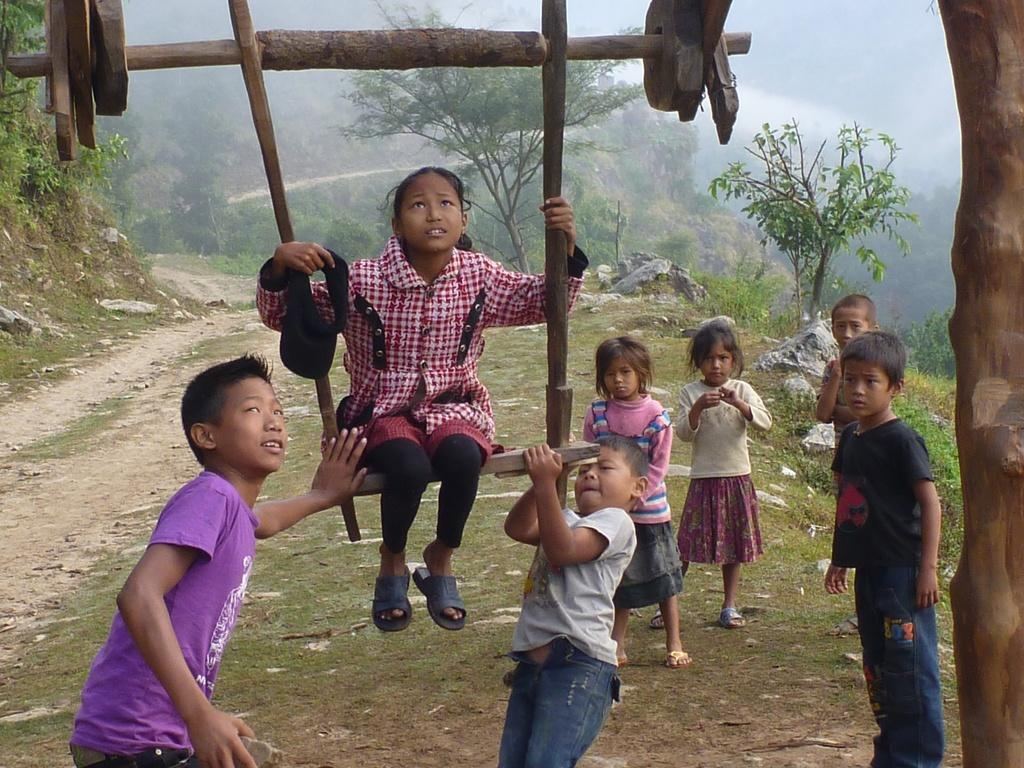What are the children in the image doing? The children are standing in the image. Can you describe the girl's position in the image? A girl is sitting on a wooden swing. How can you differentiate the children in the image? The children are wearing different color dresses. What can be seen in the background of the image? There are trees and stones visible in the background. What type of linen is draped over the swing in the image? There is no linen draped over the swing in the image; it is a wooden swing. How many spiders are crawling on the children in the image? There are no spiders present in the image; the children are standing and the girl is sitting on a swing. 